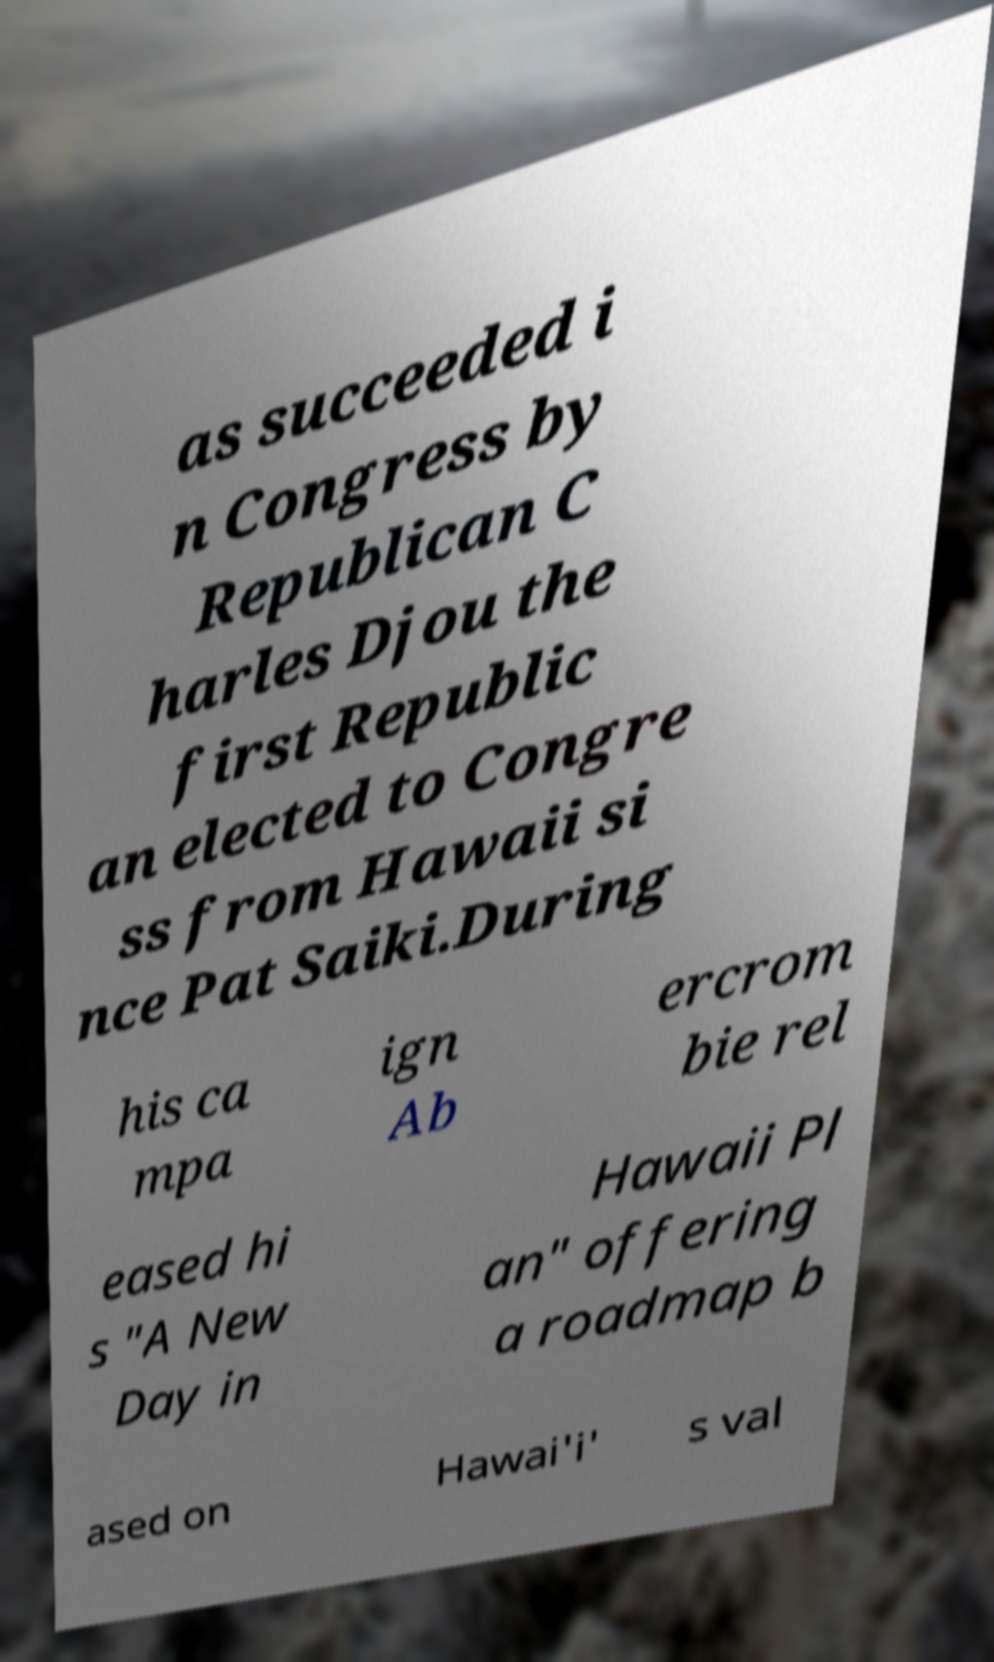Could you assist in decoding the text presented in this image and type it out clearly? as succeeded i n Congress by Republican C harles Djou the first Republic an elected to Congre ss from Hawaii si nce Pat Saiki.During his ca mpa ign Ab ercrom bie rel eased hi s "A New Day in Hawaii Pl an" offering a roadmap b ased on Hawai'i' s val 